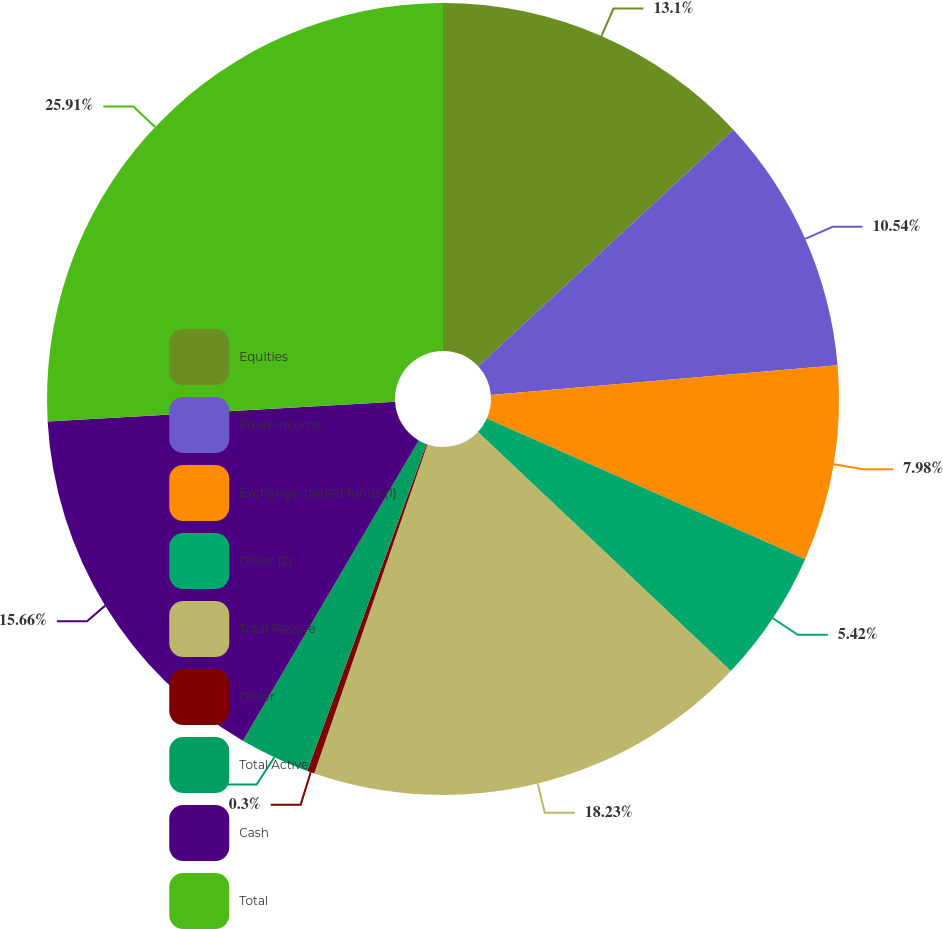Convert chart. <chart><loc_0><loc_0><loc_500><loc_500><pie_chart><fcel>Equities<fcel>Fixed-income<fcel>Exchange-traded funds (1)<fcel>Other (2)<fcel>Total Passive<fcel>Other<fcel>Total Active<fcel>Cash<fcel>Total<nl><fcel>13.1%<fcel>10.54%<fcel>7.98%<fcel>5.42%<fcel>18.22%<fcel>0.3%<fcel>2.86%<fcel>15.66%<fcel>25.9%<nl></chart> 